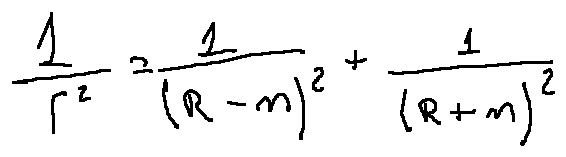<formula> <loc_0><loc_0><loc_500><loc_500>\frac { 1 } { r ^ { 2 } } = \frac { 1 } { ( R - m ) ^ { 2 } } + \frac { 1 } { ( R + m ) ^ { 2 } }</formula> 